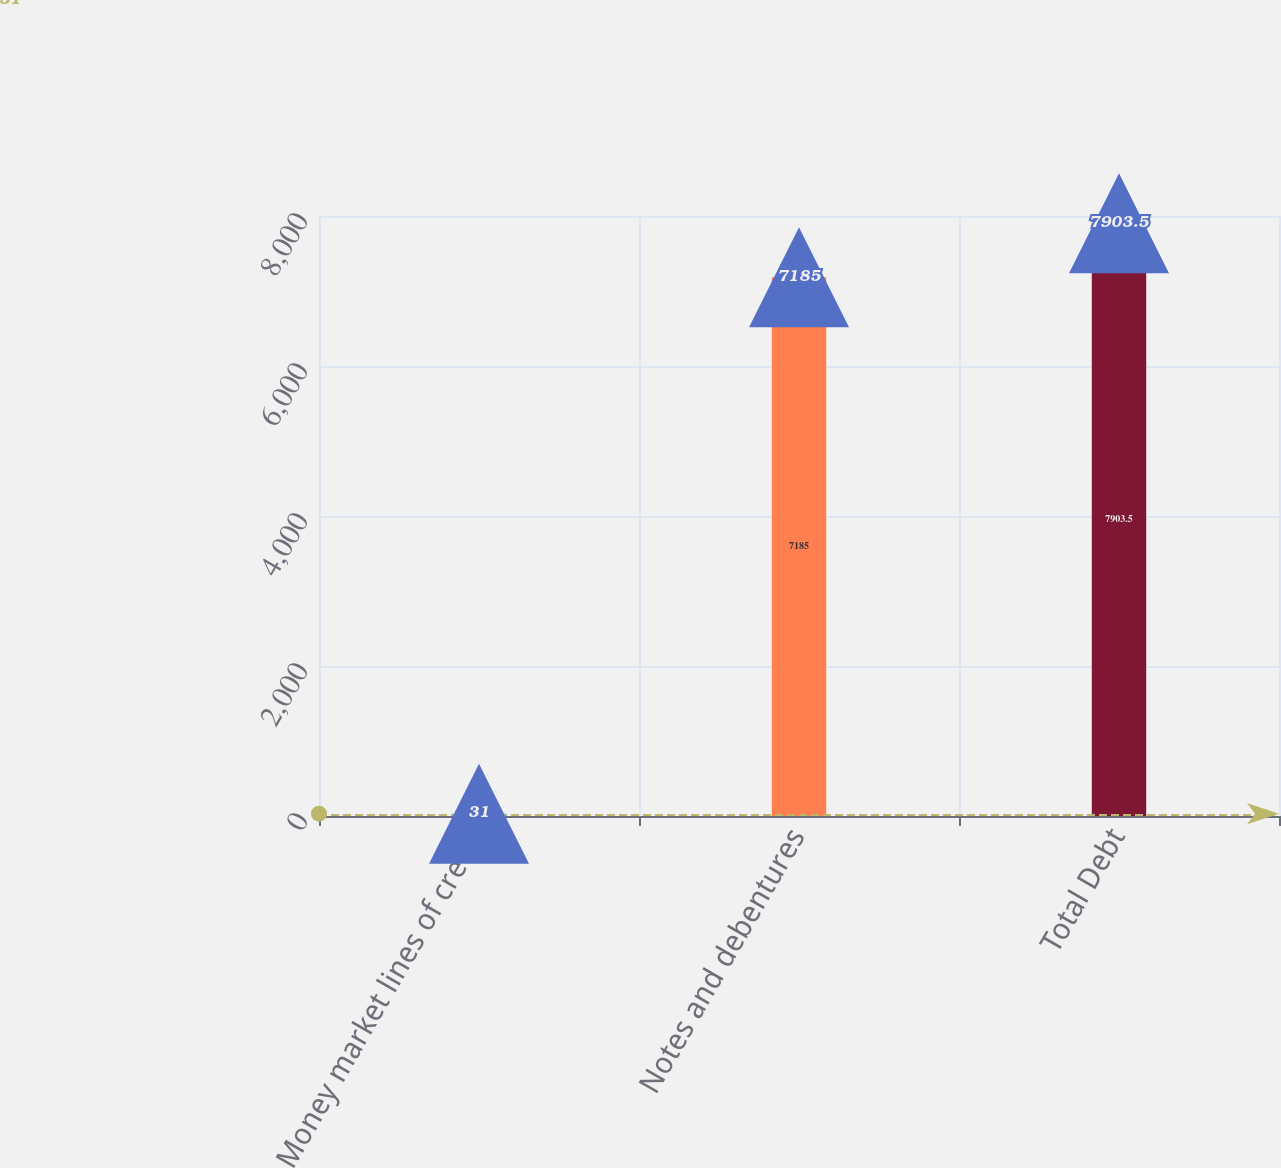Convert chart to OTSL. <chart><loc_0><loc_0><loc_500><loc_500><bar_chart><fcel>Money market lines of credit<fcel>Notes and debentures<fcel>Total Debt<nl><fcel>31<fcel>7185<fcel>7903.5<nl></chart> 